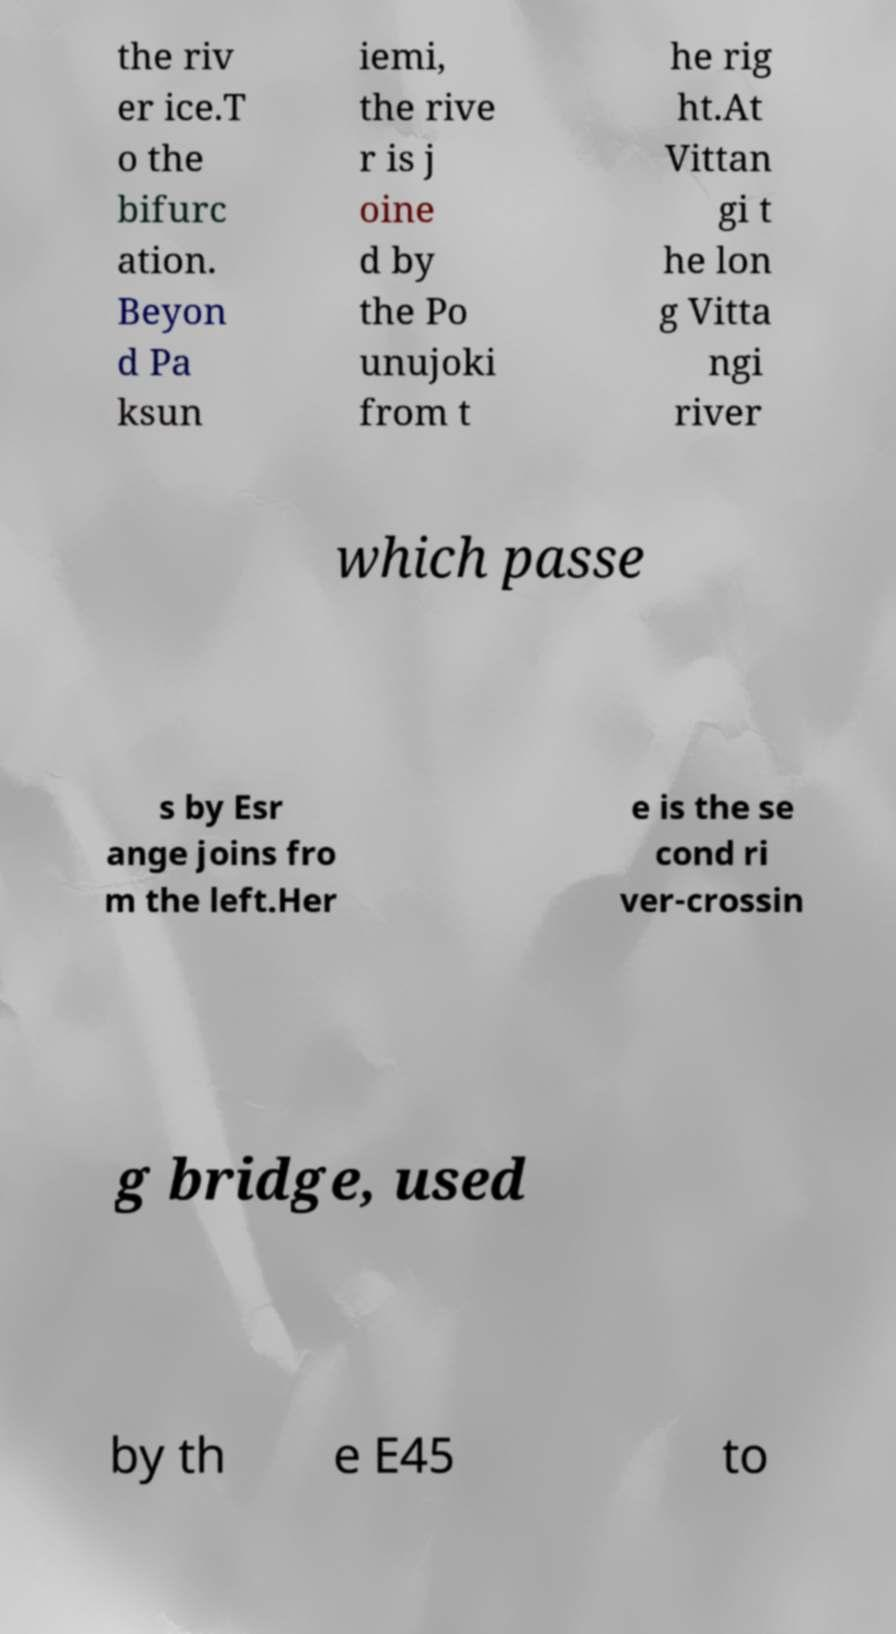Please identify and transcribe the text found in this image. the riv er ice.T o the bifurc ation. Beyon d Pa ksun iemi, the rive r is j oine d by the Po unujoki from t he rig ht.At Vittan gi t he lon g Vitta ngi river which passe s by Esr ange joins fro m the left.Her e is the se cond ri ver-crossin g bridge, used by th e E45 to 